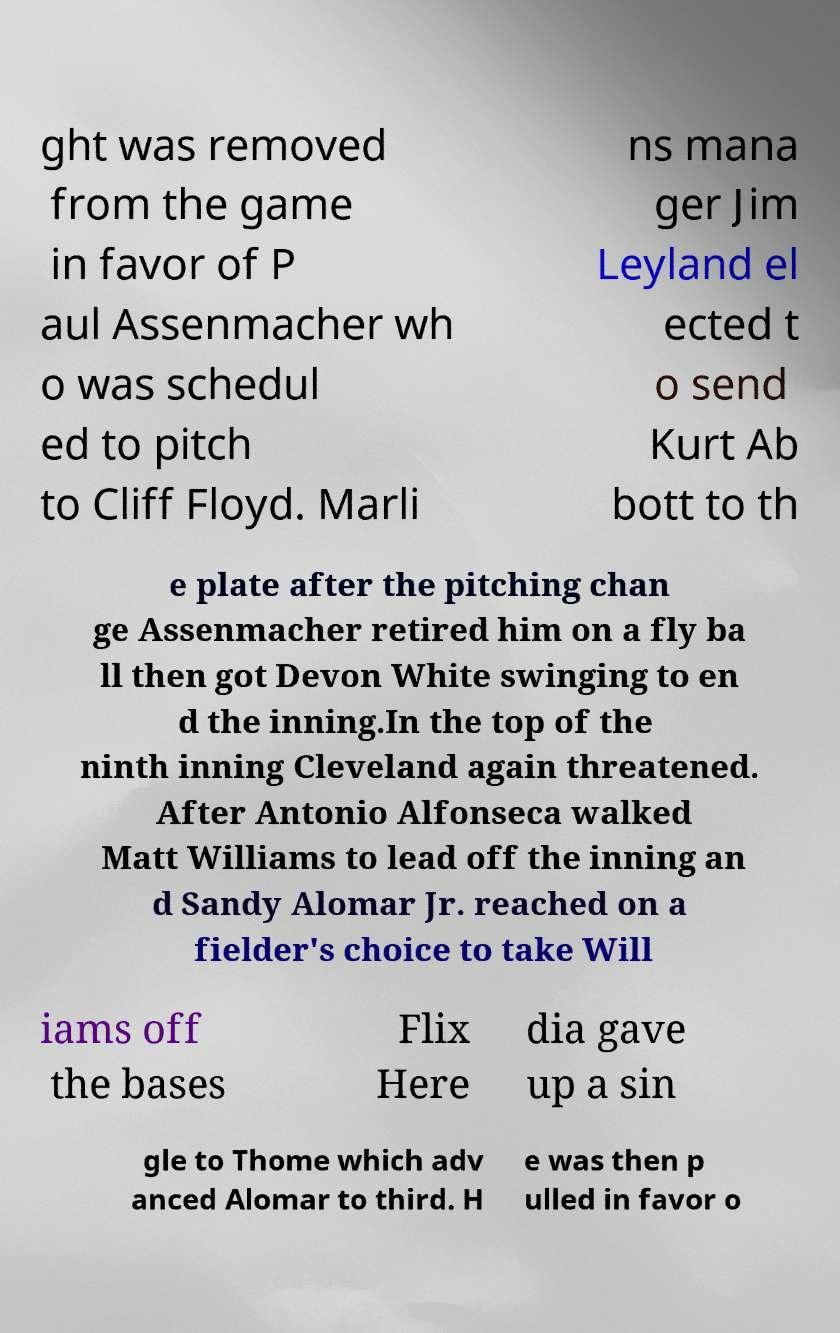I need the written content from this picture converted into text. Can you do that? ght was removed from the game in favor of P aul Assenmacher wh o was schedul ed to pitch to Cliff Floyd. Marli ns mana ger Jim Leyland el ected t o send Kurt Ab bott to th e plate after the pitching chan ge Assenmacher retired him on a fly ba ll then got Devon White swinging to en d the inning.In the top of the ninth inning Cleveland again threatened. After Antonio Alfonseca walked Matt Williams to lead off the inning an d Sandy Alomar Jr. reached on a fielder's choice to take Will iams off the bases Flix Here dia gave up a sin gle to Thome which adv anced Alomar to third. H e was then p ulled in favor o 